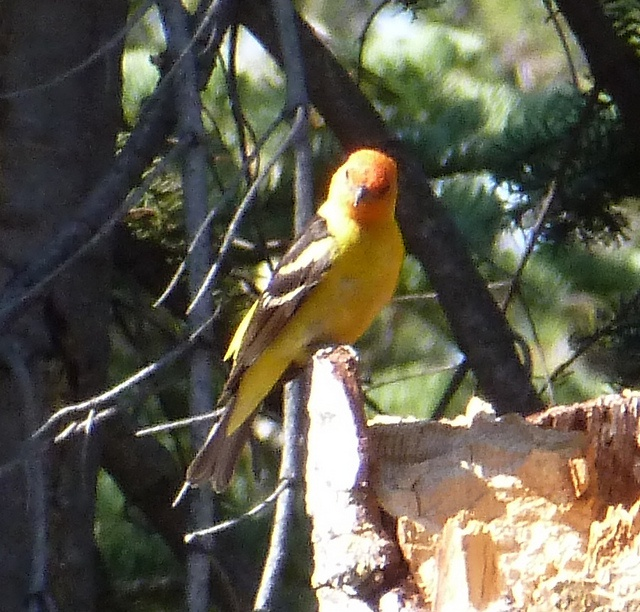Describe the objects in this image and their specific colors. I can see a bird in black, olive, maroon, and gray tones in this image. 